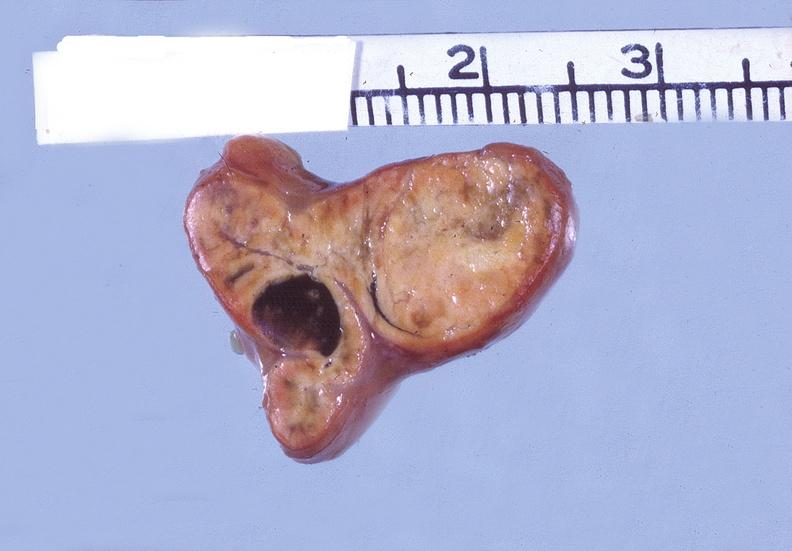where does this belong to?
Answer the question using a single word or phrase. Endocrine system 